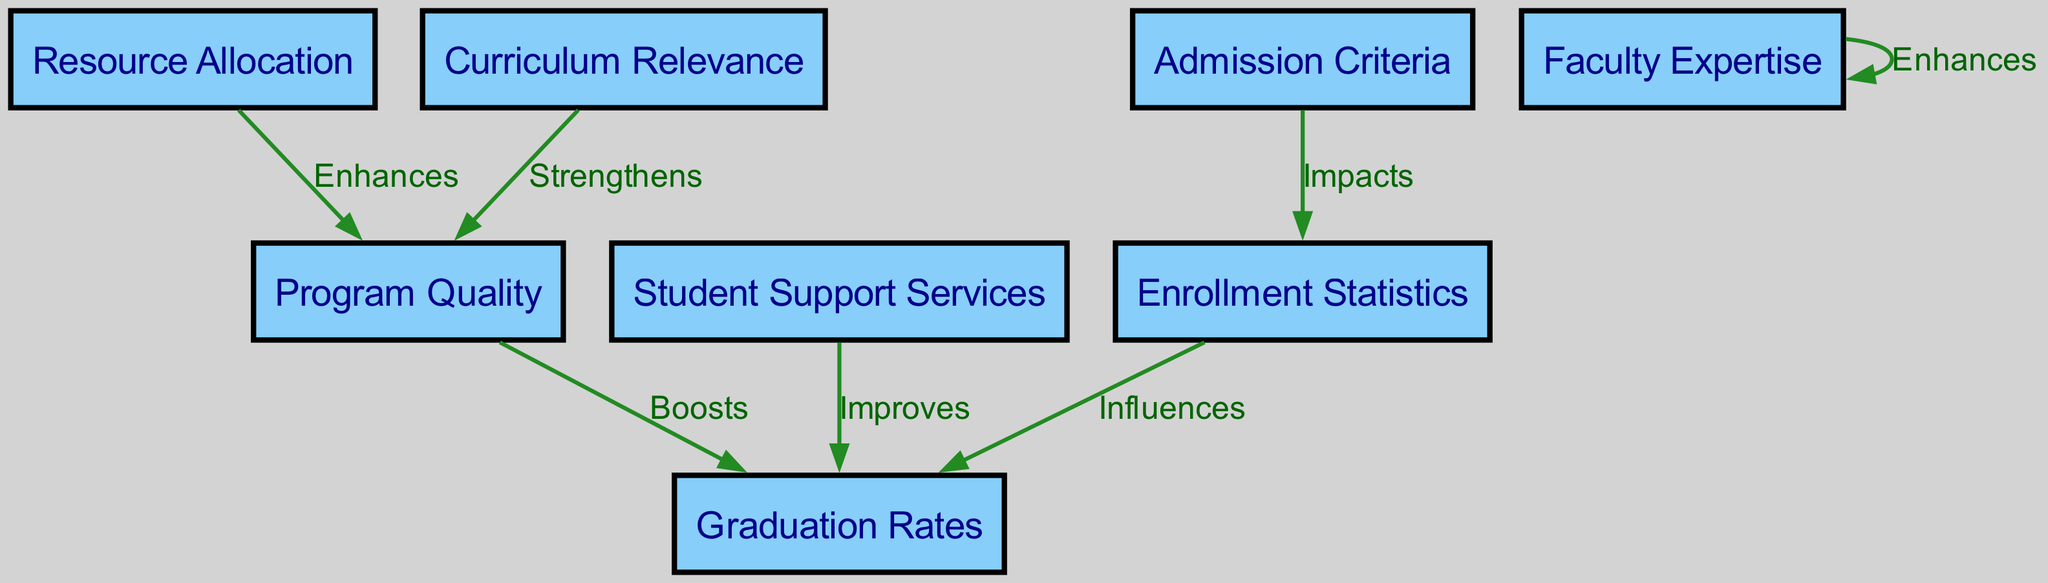What nodes are present in the diagram? The diagram includes the following nodes: Enrollment Statistics, Graduation Rates, Program Quality, Resource Allocation, Student Support Services, Admission Criteria, Curriculum Relevance, and Faculty Expertise.
Answer: Enrollment Statistics, Graduation Rates, Program Quality, Resource Allocation, Student Support Services, Admission Criteria, Curriculum Relevance, Faculty Expertise How many edges are there in total? The diagram has 7 edges connecting the nodes, showing relationships such as impacts, influences, enhances, boosts, and improves.
Answer: 7 What impacts enrollment statistics? The diagram shows that enrollment statistics are impacted by admission criteria.
Answer: Admission Criteria Which node boosts graduation rates? The diagram indicates that graduation rates are boosted by program quality.
Answer: Program Quality What enhances program quality? The diagram shows that resource allocation enhances program quality.
Answer: Resource Allocation Which factors lead to improved graduation rates? The diagram states that graduation rates are improved by both student support services and program quality. This means multiple factors are required for improvement.
Answer: Student Support Services, Program Quality What strengthens program quality? According to the diagram, curriculum relevance strengthens program quality.
Answer: Curriculum Relevance How does student support affect graduation rates? The diagram indicates that student support improves graduation rates, suggesting a direct positive influence on student success.
Answer: Improves What is the relationship between enrollment statistics and graduation rates? The diagram states that enrollment statistics influence graduation rates, indicating a connection between these two metrics in healthcare training.
Answer: Influences 